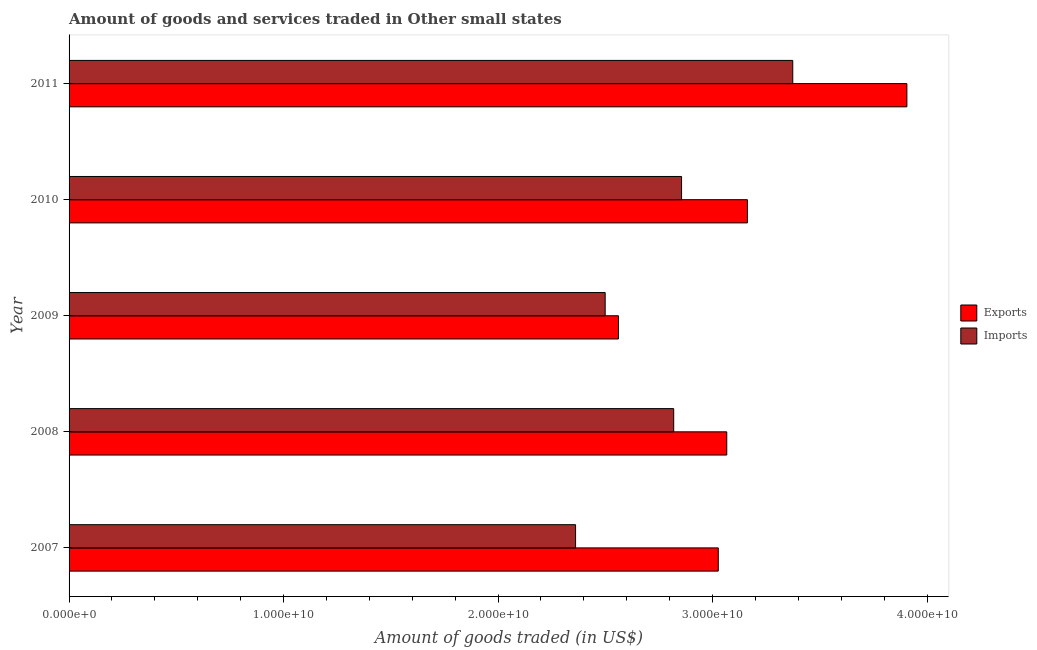Are the number of bars per tick equal to the number of legend labels?
Provide a succinct answer. Yes. How many bars are there on the 1st tick from the top?
Offer a terse response. 2. What is the label of the 2nd group of bars from the top?
Provide a succinct answer. 2010. What is the amount of goods imported in 2010?
Give a very brief answer. 2.86e+1. Across all years, what is the maximum amount of goods imported?
Provide a succinct answer. 3.37e+1. Across all years, what is the minimum amount of goods exported?
Offer a very short reply. 2.56e+1. In which year was the amount of goods imported maximum?
Your answer should be very brief. 2011. What is the total amount of goods imported in the graph?
Offer a very short reply. 1.39e+11. What is the difference between the amount of goods exported in 2009 and that in 2011?
Offer a terse response. -1.34e+1. What is the difference between the amount of goods imported in 2009 and the amount of goods exported in 2011?
Your answer should be compact. -1.41e+1. What is the average amount of goods exported per year?
Your answer should be very brief. 3.14e+1. In the year 2007, what is the difference between the amount of goods exported and amount of goods imported?
Ensure brevity in your answer.  6.65e+09. In how many years, is the amount of goods exported greater than 34000000000 US$?
Keep it short and to the point. 1. What is the ratio of the amount of goods exported in 2007 to that in 2009?
Provide a succinct answer. 1.18. Is the amount of goods exported in 2009 less than that in 2011?
Provide a short and direct response. Yes. What is the difference between the highest and the second highest amount of goods imported?
Make the answer very short. 5.18e+09. What is the difference between the highest and the lowest amount of goods exported?
Ensure brevity in your answer.  1.34e+1. What does the 2nd bar from the top in 2007 represents?
Make the answer very short. Exports. What does the 1st bar from the bottom in 2008 represents?
Offer a terse response. Exports. How many bars are there?
Offer a very short reply. 10. Are all the bars in the graph horizontal?
Keep it short and to the point. Yes. What is the difference between two consecutive major ticks on the X-axis?
Your answer should be very brief. 1.00e+1. Does the graph contain any zero values?
Provide a succinct answer. No. Does the graph contain grids?
Your answer should be very brief. No. What is the title of the graph?
Your response must be concise. Amount of goods and services traded in Other small states. Does "Under-five" appear as one of the legend labels in the graph?
Your answer should be compact. No. What is the label or title of the X-axis?
Offer a terse response. Amount of goods traded (in US$). What is the label or title of the Y-axis?
Your answer should be compact. Year. What is the Amount of goods traded (in US$) of Exports in 2007?
Your answer should be very brief. 3.03e+1. What is the Amount of goods traded (in US$) of Imports in 2007?
Your answer should be very brief. 2.36e+1. What is the Amount of goods traded (in US$) of Exports in 2008?
Your response must be concise. 3.07e+1. What is the Amount of goods traded (in US$) in Imports in 2008?
Your response must be concise. 2.82e+1. What is the Amount of goods traded (in US$) of Exports in 2009?
Offer a very short reply. 2.56e+1. What is the Amount of goods traded (in US$) of Imports in 2009?
Your answer should be very brief. 2.50e+1. What is the Amount of goods traded (in US$) in Exports in 2010?
Give a very brief answer. 3.16e+1. What is the Amount of goods traded (in US$) of Imports in 2010?
Provide a succinct answer. 2.86e+1. What is the Amount of goods traded (in US$) in Exports in 2011?
Ensure brevity in your answer.  3.91e+1. What is the Amount of goods traded (in US$) of Imports in 2011?
Make the answer very short. 3.37e+1. Across all years, what is the maximum Amount of goods traded (in US$) in Exports?
Provide a succinct answer. 3.91e+1. Across all years, what is the maximum Amount of goods traded (in US$) in Imports?
Offer a terse response. 3.37e+1. Across all years, what is the minimum Amount of goods traded (in US$) of Exports?
Offer a terse response. 2.56e+1. Across all years, what is the minimum Amount of goods traded (in US$) of Imports?
Provide a short and direct response. 2.36e+1. What is the total Amount of goods traded (in US$) in Exports in the graph?
Offer a very short reply. 1.57e+11. What is the total Amount of goods traded (in US$) of Imports in the graph?
Make the answer very short. 1.39e+11. What is the difference between the Amount of goods traded (in US$) in Exports in 2007 and that in 2008?
Offer a terse response. -3.96e+08. What is the difference between the Amount of goods traded (in US$) in Imports in 2007 and that in 2008?
Your answer should be compact. -4.57e+09. What is the difference between the Amount of goods traded (in US$) of Exports in 2007 and that in 2009?
Your answer should be very brief. 4.65e+09. What is the difference between the Amount of goods traded (in US$) in Imports in 2007 and that in 2009?
Provide a short and direct response. -1.38e+09. What is the difference between the Amount of goods traded (in US$) of Exports in 2007 and that in 2010?
Ensure brevity in your answer.  -1.36e+09. What is the difference between the Amount of goods traded (in US$) in Imports in 2007 and that in 2010?
Provide a succinct answer. -4.94e+09. What is the difference between the Amount of goods traded (in US$) in Exports in 2007 and that in 2011?
Keep it short and to the point. -8.79e+09. What is the difference between the Amount of goods traded (in US$) of Imports in 2007 and that in 2011?
Ensure brevity in your answer.  -1.01e+1. What is the difference between the Amount of goods traded (in US$) in Exports in 2008 and that in 2009?
Provide a succinct answer. 5.05e+09. What is the difference between the Amount of goods traded (in US$) in Imports in 2008 and that in 2009?
Give a very brief answer. 3.19e+09. What is the difference between the Amount of goods traded (in US$) of Exports in 2008 and that in 2010?
Your answer should be very brief. -9.63e+08. What is the difference between the Amount of goods traded (in US$) in Imports in 2008 and that in 2010?
Provide a short and direct response. -3.67e+08. What is the difference between the Amount of goods traded (in US$) in Exports in 2008 and that in 2011?
Ensure brevity in your answer.  -8.40e+09. What is the difference between the Amount of goods traded (in US$) of Imports in 2008 and that in 2011?
Ensure brevity in your answer.  -5.55e+09. What is the difference between the Amount of goods traded (in US$) of Exports in 2009 and that in 2010?
Your answer should be compact. -6.01e+09. What is the difference between the Amount of goods traded (in US$) in Imports in 2009 and that in 2010?
Your answer should be compact. -3.56e+09. What is the difference between the Amount of goods traded (in US$) in Exports in 2009 and that in 2011?
Keep it short and to the point. -1.34e+1. What is the difference between the Amount of goods traded (in US$) of Imports in 2009 and that in 2011?
Offer a terse response. -8.75e+09. What is the difference between the Amount of goods traded (in US$) of Exports in 2010 and that in 2011?
Offer a very short reply. -7.43e+09. What is the difference between the Amount of goods traded (in US$) of Imports in 2010 and that in 2011?
Your response must be concise. -5.18e+09. What is the difference between the Amount of goods traded (in US$) of Exports in 2007 and the Amount of goods traded (in US$) of Imports in 2008?
Offer a terse response. 2.08e+09. What is the difference between the Amount of goods traded (in US$) of Exports in 2007 and the Amount of goods traded (in US$) of Imports in 2009?
Your response must be concise. 5.27e+09. What is the difference between the Amount of goods traded (in US$) of Exports in 2007 and the Amount of goods traded (in US$) of Imports in 2010?
Your answer should be very brief. 1.71e+09. What is the difference between the Amount of goods traded (in US$) in Exports in 2007 and the Amount of goods traded (in US$) in Imports in 2011?
Your response must be concise. -3.47e+09. What is the difference between the Amount of goods traded (in US$) in Exports in 2008 and the Amount of goods traded (in US$) in Imports in 2009?
Your response must be concise. 5.67e+09. What is the difference between the Amount of goods traded (in US$) of Exports in 2008 and the Amount of goods traded (in US$) of Imports in 2010?
Your response must be concise. 2.11e+09. What is the difference between the Amount of goods traded (in US$) of Exports in 2008 and the Amount of goods traded (in US$) of Imports in 2011?
Your response must be concise. -3.08e+09. What is the difference between the Amount of goods traded (in US$) of Exports in 2009 and the Amount of goods traded (in US$) of Imports in 2010?
Make the answer very short. -2.94e+09. What is the difference between the Amount of goods traded (in US$) of Exports in 2009 and the Amount of goods traded (in US$) of Imports in 2011?
Provide a succinct answer. -8.13e+09. What is the difference between the Amount of goods traded (in US$) of Exports in 2010 and the Amount of goods traded (in US$) of Imports in 2011?
Your answer should be compact. -2.11e+09. What is the average Amount of goods traded (in US$) in Exports per year?
Your response must be concise. 3.14e+1. What is the average Amount of goods traded (in US$) in Imports per year?
Make the answer very short. 2.78e+1. In the year 2007, what is the difference between the Amount of goods traded (in US$) of Exports and Amount of goods traded (in US$) of Imports?
Keep it short and to the point. 6.65e+09. In the year 2008, what is the difference between the Amount of goods traded (in US$) of Exports and Amount of goods traded (in US$) of Imports?
Provide a succinct answer. 2.47e+09. In the year 2009, what is the difference between the Amount of goods traded (in US$) in Exports and Amount of goods traded (in US$) in Imports?
Keep it short and to the point. 6.19e+08. In the year 2010, what is the difference between the Amount of goods traded (in US$) of Exports and Amount of goods traded (in US$) of Imports?
Provide a succinct answer. 3.07e+09. In the year 2011, what is the difference between the Amount of goods traded (in US$) of Exports and Amount of goods traded (in US$) of Imports?
Ensure brevity in your answer.  5.32e+09. What is the ratio of the Amount of goods traded (in US$) of Exports in 2007 to that in 2008?
Offer a very short reply. 0.99. What is the ratio of the Amount of goods traded (in US$) in Imports in 2007 to that in 2008?
Offer a terse response. 0.84. What is the ratio of the Amount of goods traded (in US$) of Exports in 2007 to that in 2009?
Keep it short and to the point. 1.18. What is the ratio of the Amount of goods traded (in US$) in Imports in 2007 to that in 2009?
Offer a terse response. 0.94. What is the ratio of the Amount of goods traded (in US$) in Exports in 2007 to that in 2010?
Make the answer very short. 0.96. What is the ratio of the Amount of goods traded (in US$) in Imports in 2007 to that in 2010?
Offer a very short reply. 0.83. What is the ratio of the Amount of goods traded (in US$) of Exports in 2007 to that in 2011?
Provide a short and direct response. 0.77. What is the ratio of the Amount of goods traded (in US$) of Imports in 2007 to that in 2011?
Your response must be concise. 0.7. What is the ratio of the Amount of goods traded (in US$) in Exports in 2008 to that in 2009?
Offer a terse response. 1.2. What is the ratio of the Amount of goods traded (in US$) of Imports in 2008 to that in 2009?
Offer a terse response. 1.13. What is the ratio of the Amount of goods traded (in US$) in Exports in 2008 to that in 2010?
Offer a terse response. 0.97. What is the ratio of the Amount of goods traded (in US$) of Imports in 2008 to that in 2010?
Ensure brevity in your answer.  0.99. What is the ratio of the Amount of goods traded (in US$) in Exports in 2008 to that in 2011?
Offer a very short reply. 0.79. What is the ratio of the Amount of goods traded (in US$) in Imports in 2008 to that in 2011?
Ensure brevity in your answer.  0.84. What is the ratio of the Amount of goods traded (in US$) of Exports in 2009 to that in 2010?
Your answer should be very brief. 0.81. What is the ratio of the Amount of goods traded (in US$) in Imports in 2009 to that in 2010?
Your answer should be compact. 0.88. What is the ratio of the Amount of goods traded (in US$) of Exports in 2009 to that in 2011?
Ensure brevity in your answer.  0.66. What is the ratio of the Amount of goods traded (in US$) of Imports in 2009 to that in 2011?
Provide a short and direct response. 0.74. What is the ratio of the Amount of goods traded (in US$) in Exports in 2010 to that in 2011?
Your answer should be very brief. 0.81. What is the ratio of the Amount of goods traded (in US$) of Imports in 2010 to that in 2011?
Keep it short and to the point. 0.85. What is the difference between the highest and the second highest Amount of goods traded (in US$) in Exports?
Offer a very short reply. 7.43e+09. What is the difference between the highest and the second highest Amount of goods traded (in US$) of Imports?
Offer a very short reply. 5.18e+09. What is the difference between the highest and the lowest Amount of goods traded (in US$) of Exports?
Your response must be concise. 1.34e+1. What is the difference between the highest and the lowest Amount of goods traded (in US$) in Imports?
Your answer should be very brief. 1.01e+1. 